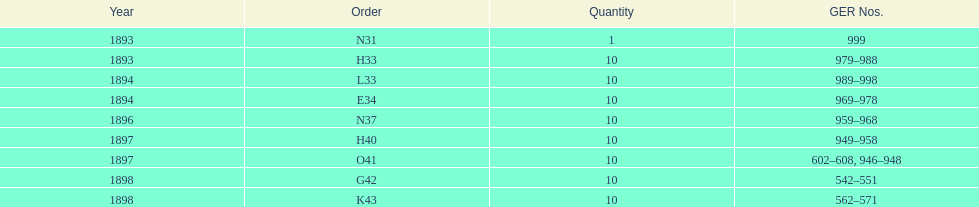In which year was g42, 1898 or 1894? 1898. 